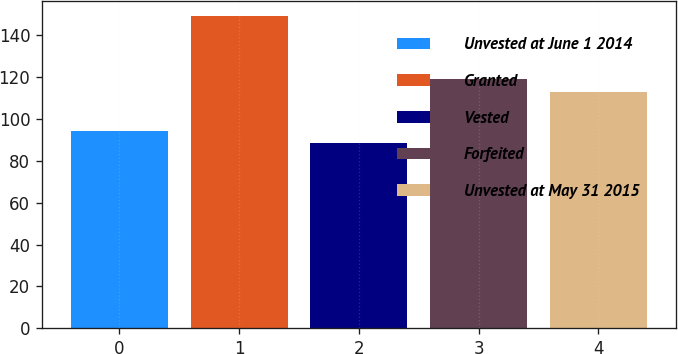<chart> <loc_0><loc_0><loc_500><loc_500><bar_chart><fcel>Unvested at June 1 2014<fcel>Granted<fcel>Vested<fcel>Forfeited<fcel>Unvested at May 31 2015<nl><fcel>94.39<fcel>148.89<fcel>88.33<fcel>118.93<fcel>112.87<nl></chart> 